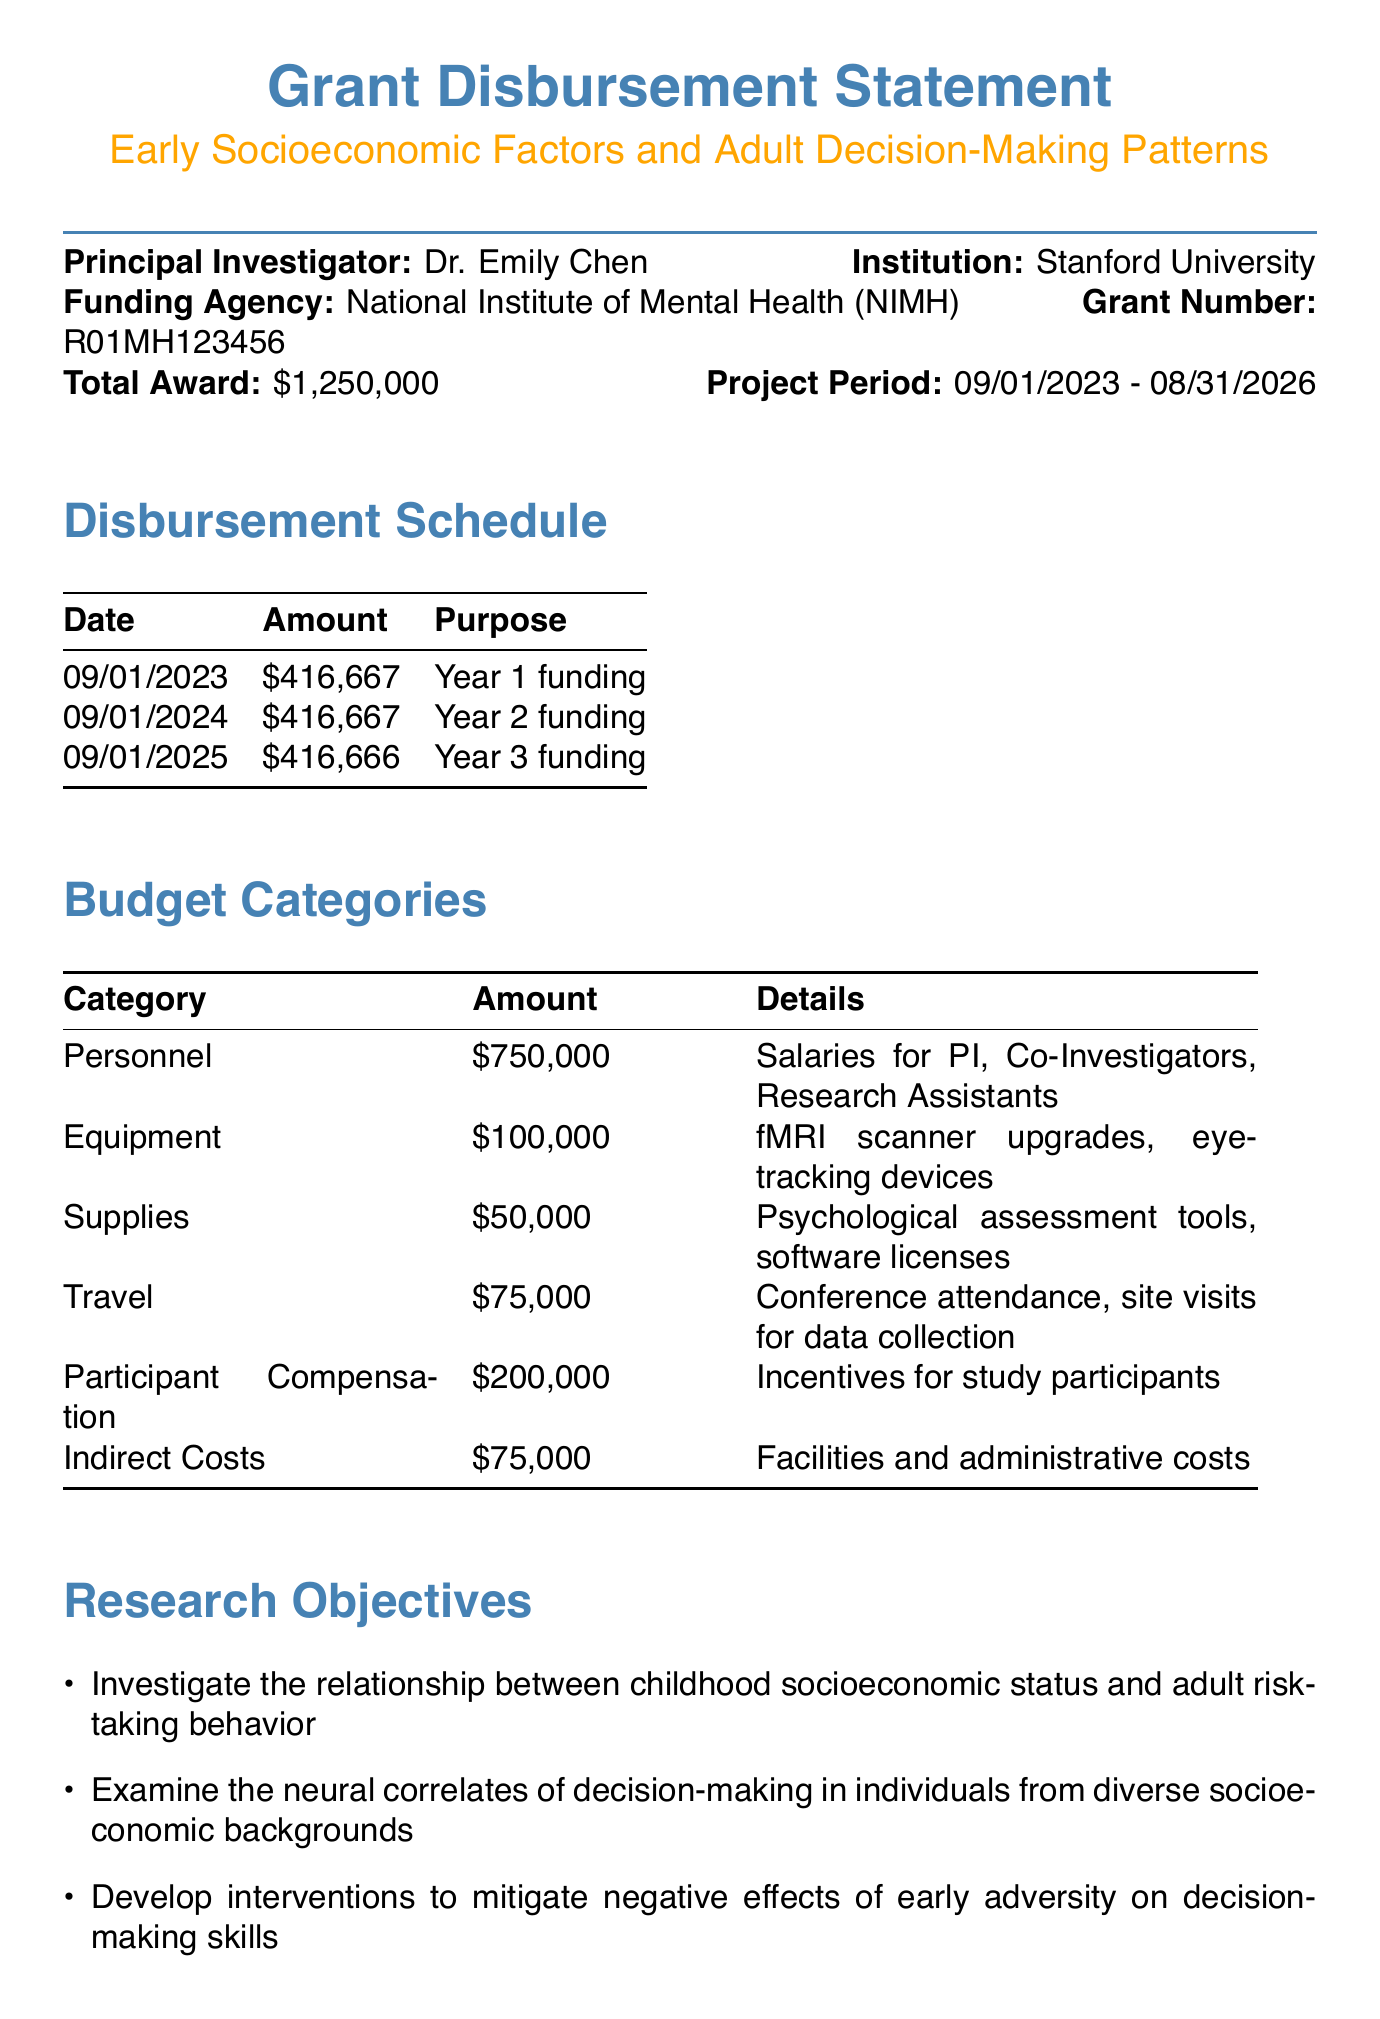What is the project title? The project title is mentioned at the beginning of the document as "Early Socioeconomic Factors and Adult Decision-Making Patterns".
Answer: Early Socioeconomic Factors and Adult Decision-Making Patterns Who is the principal investigator? The principal investigator is clearly stated in the document as Dr. Emily Chen.
Answer: Dr. Emily Chen What is the total award amount? The total award amount is specified in the document as $1,250,000.
Answer: $1,250,000 How many disbursements are scheduled for the project? The document lists three scheduled disbursements for the project, one for each year.
Answer: Three What is the budget category with the highest amount? The document details that the "Personnel" category has the highest budget amount of $750,000.
Answer: Personnel What is the due date for the Annual Progress Report? The document provides the due date for the Annual Progress Report as July 31, 2024.
Answer: 07/31/2024 Which institution is involved in data analysis and statistical modeling? The document indicates that Harvard University is the institution involved in data analysis and statistical modeling.
Answer: Harvard University What ethical consideration is mentioned regarding vulnerable populations? The document mentions "Informed consent procedures for vulnerable populations" as a key ethical consideration.
Answer: Informed consent procedures for vulnerable populations What is the purpose of the disbursement on September 1, 2024? The document states the purpose of the disbursement on September 1, 2024, is for Year 2 funding.
Answer: Year 2 funding 